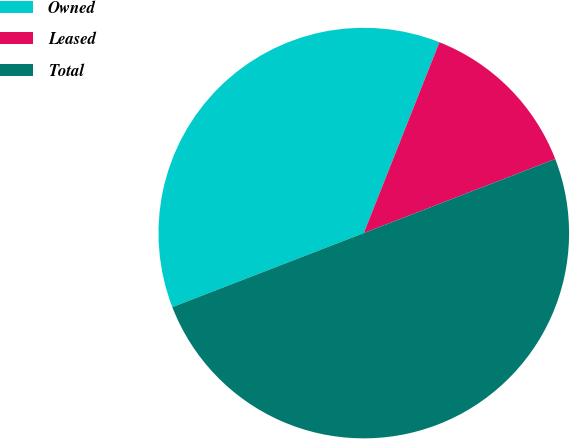Convert chart. <chart><loc_0><loc_0><loc_500><loc_500><pie_chart><fcel>Owned<fcel>Leased<fcel>Total<nl><fcel>36.88%<fcel>13.12%<fcel>50.0%<nl></chart> 